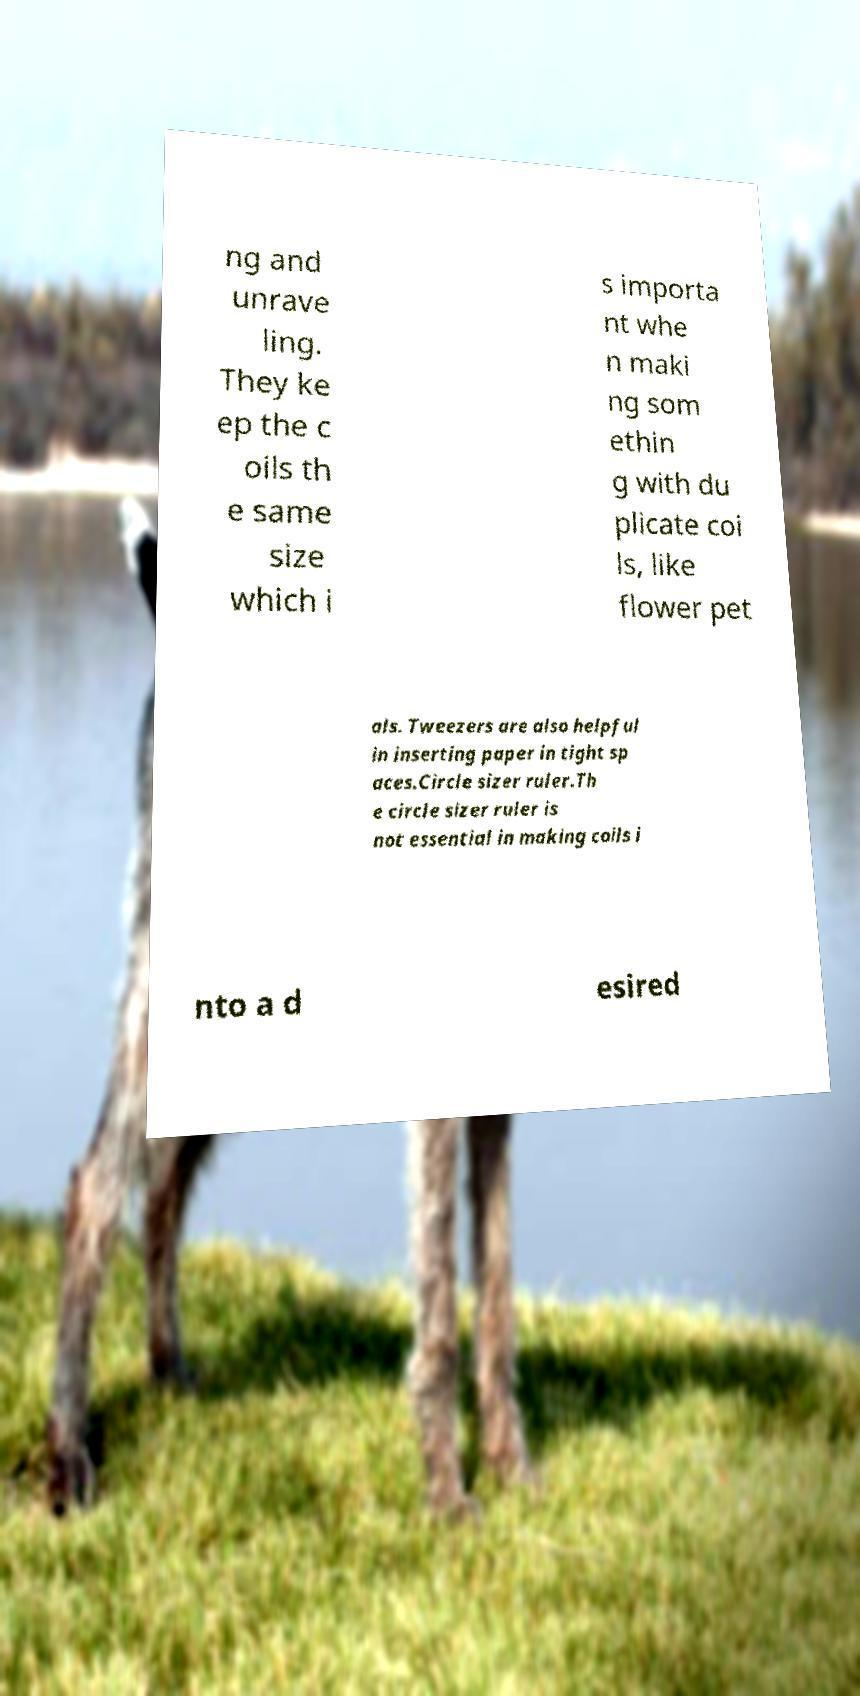Can you accurately transcribe the text from the provided image for me? ng and unrave ling. They ke ep the c oils th e same size which i s importa nt whe n maki ng som ethin g with du plicate coi ls, like flower pet als. Tweezers are also helpful in inserting paper in tight sp aces.Circle sizer ruler.Th e circle sizer ruler is not essential in making coils i nto a d esired 